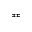<formula> <loc_0><loc_0><loc_500><loc_500>\ e q c i r c</formula> 